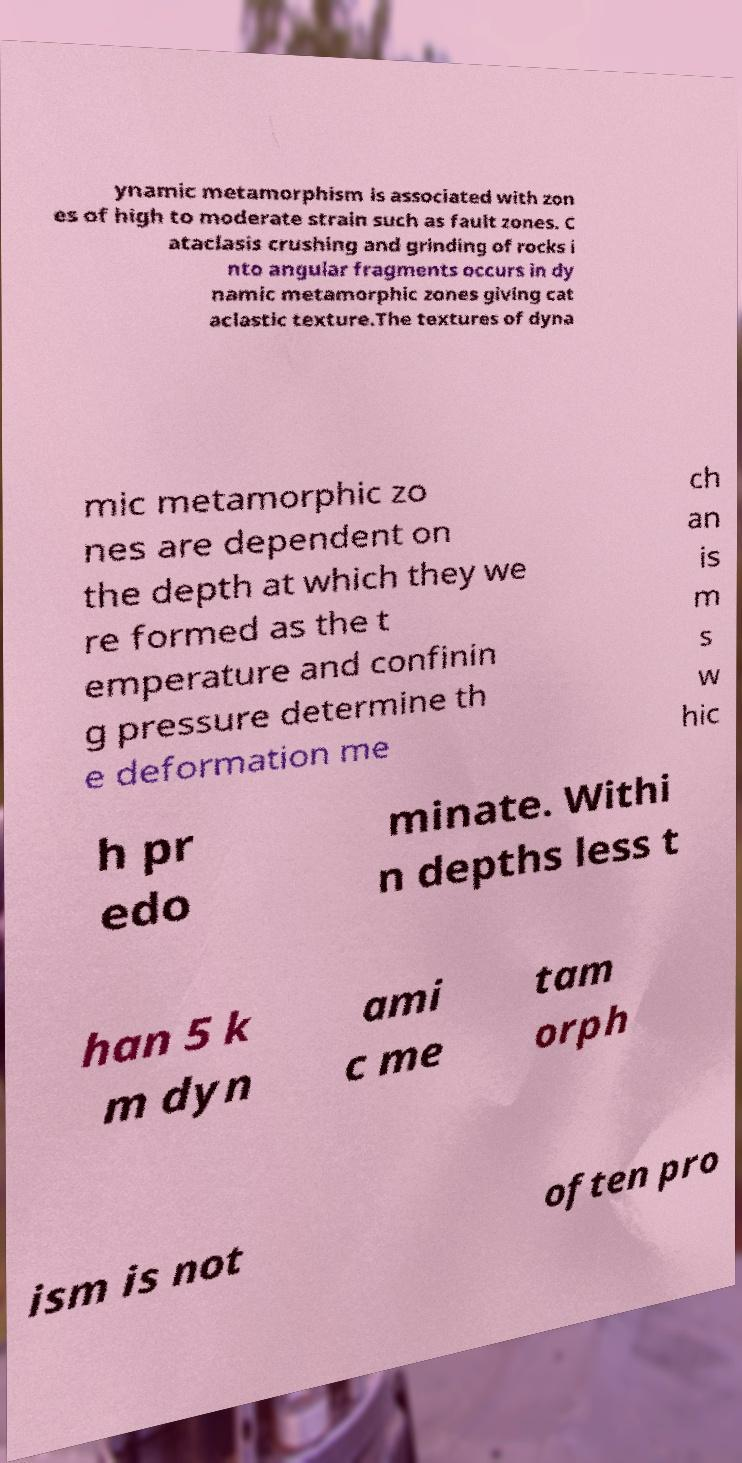Can you accurately transcribe the text from the provided image for me? ynamic metamorphism is associated with zon es of high to moderate strain such as fault zones. C ataclasis crushing and grinding of rocks i nto angular fragments occurs in dy namic metamorphic zones giving cat aclastic texture.The textures of dyna mic metamorphic zo nes are dependent on the depth at which they we re formed as the t emperature and confinin g pressure determine th e deformation me ch an is m s w hic h pr edo minate. Withi n depths less t han 5 k m dyn ami c me tam orph ism is not often pro 